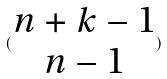Convert formula to latex. <formula><loc_0><loc_0><loc_500><loc_500>( \begin{matrix} n + k - 1 \\ n - 1 \end{matrix} )</formula> 